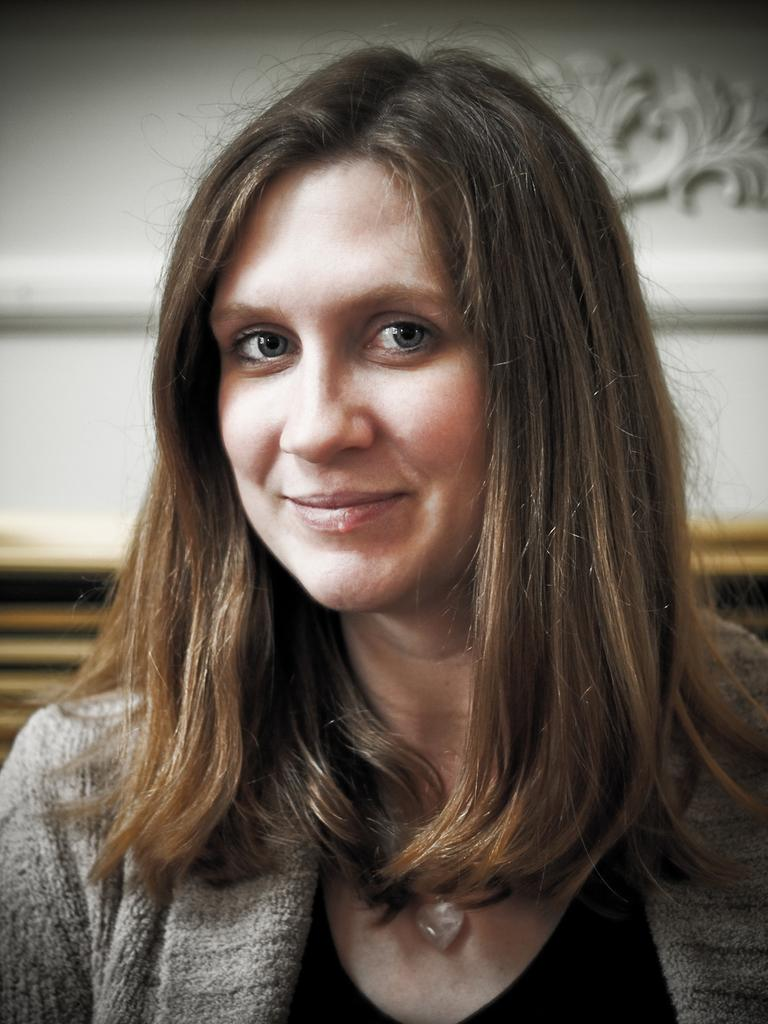Who or what is the main subject of the image? There is a person in the image. What is the person wearing? The person is wearing an ash and black color dress. What color is the background of the image? The background of the image is white. What type of cork can be seen in the person's hand in the image? There is no cork present in the image; the person is not holding anything. 